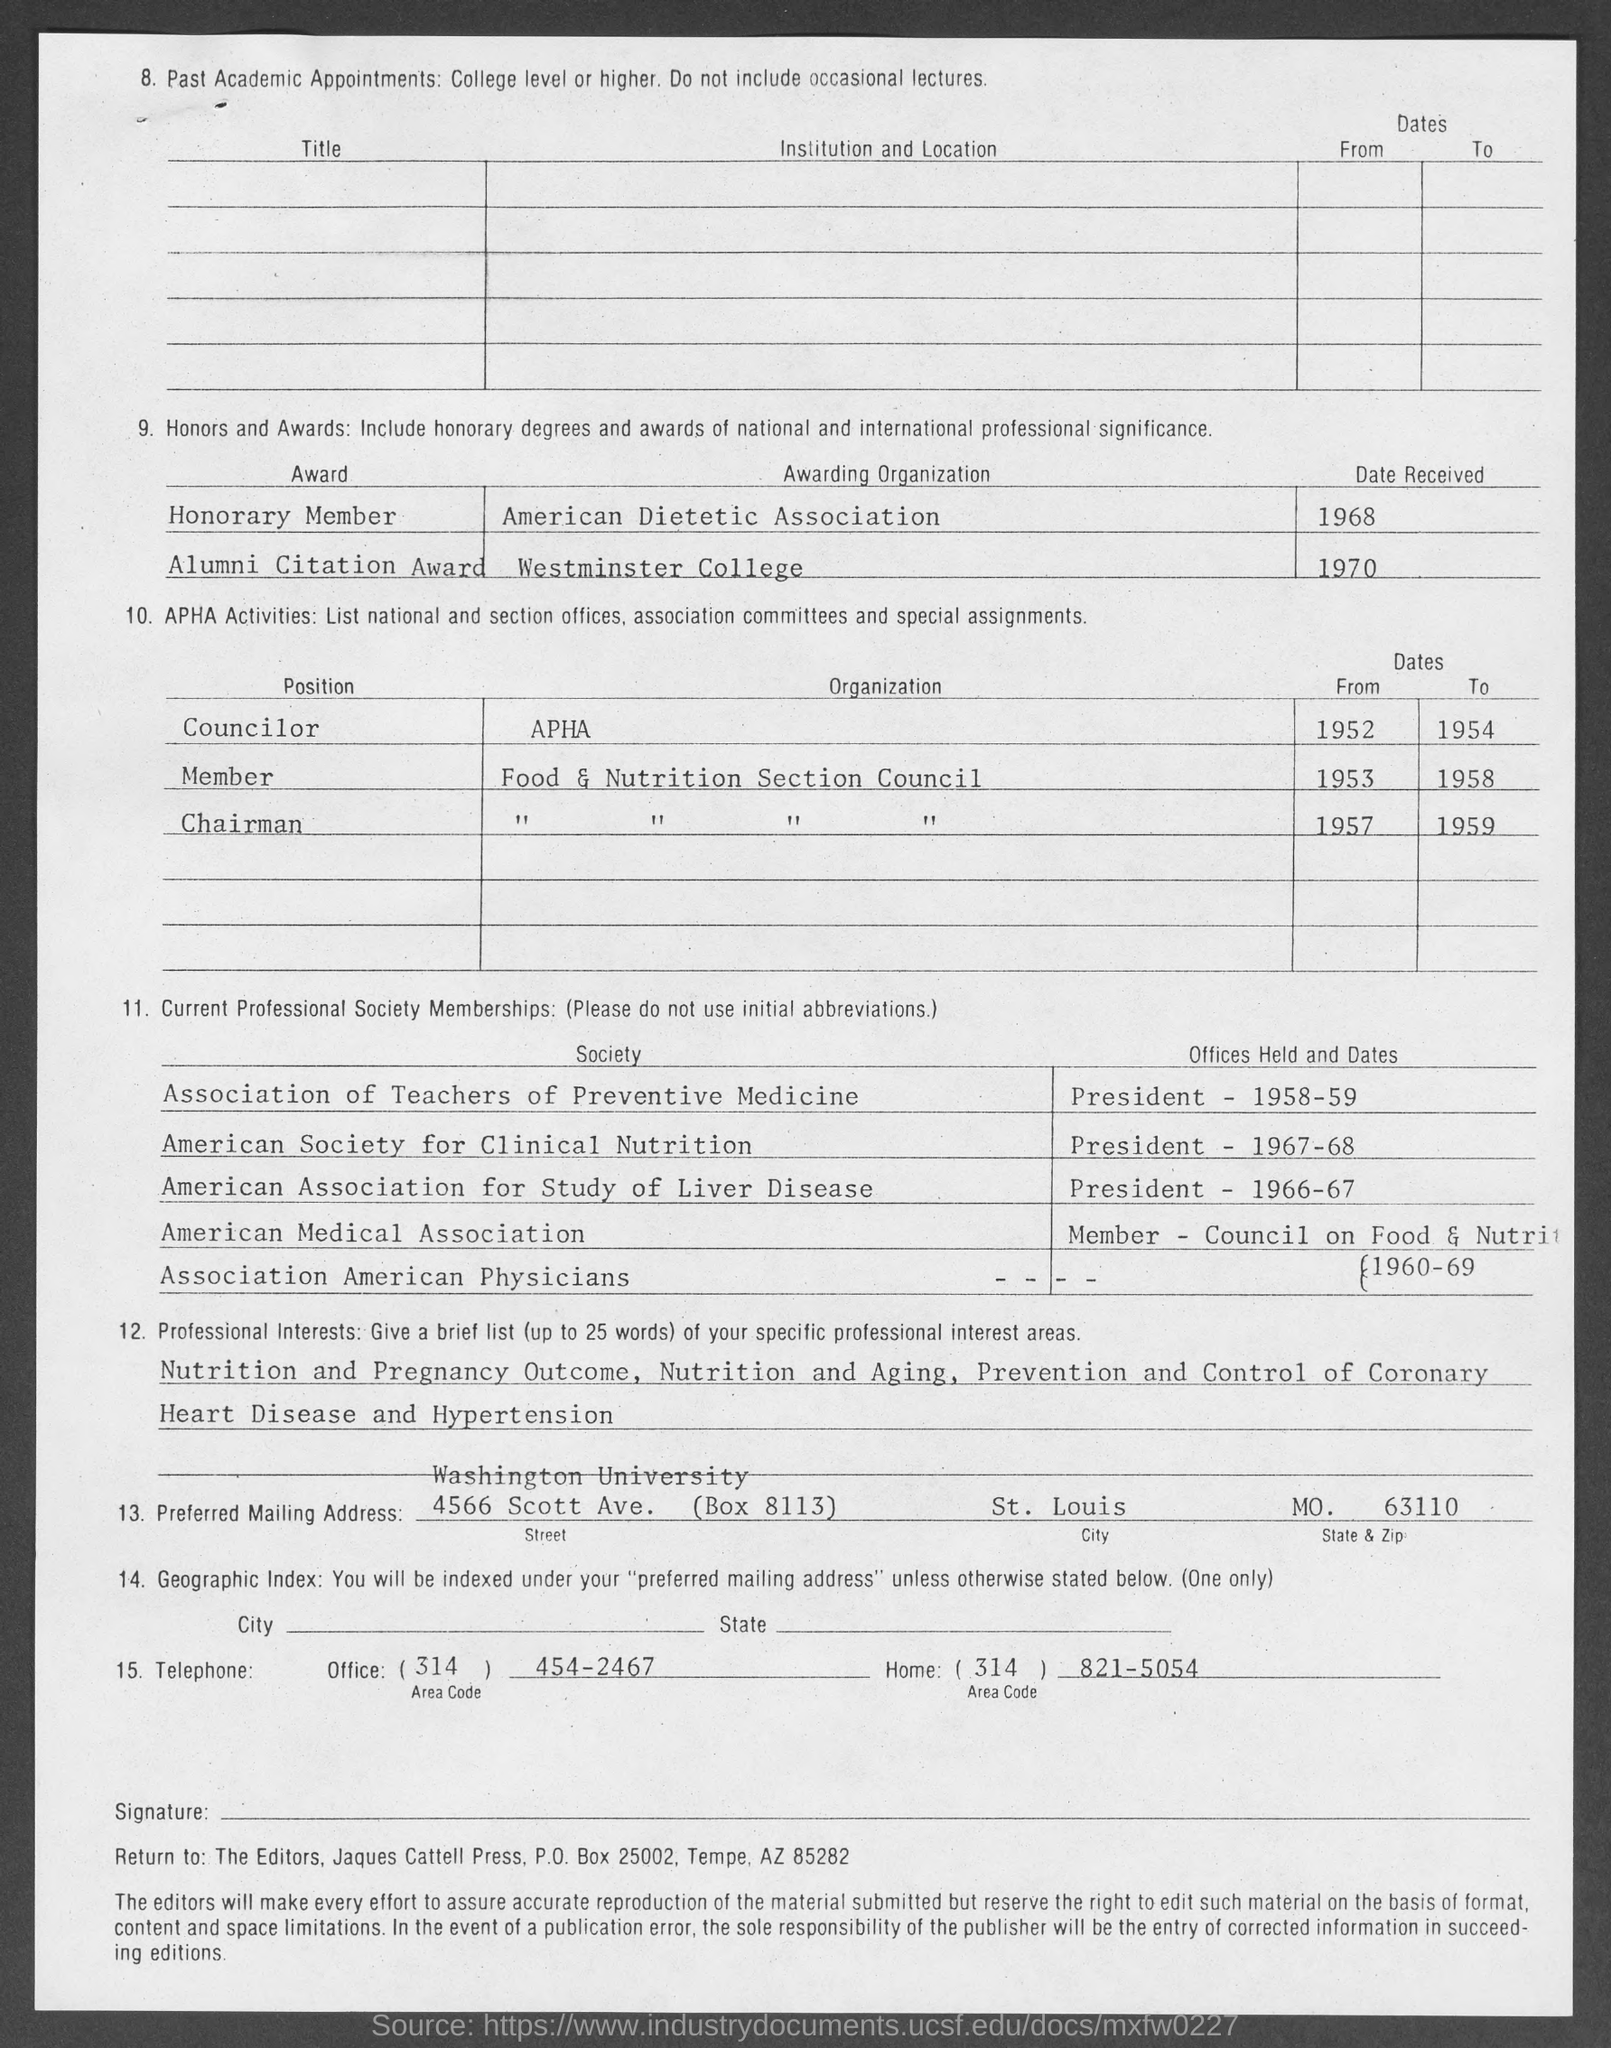What is the office telephone no. mentioned in the given page? The office telephone number listed on the document is 454-2467, located under the section for telephone numbers in the header 'Telephone'. 